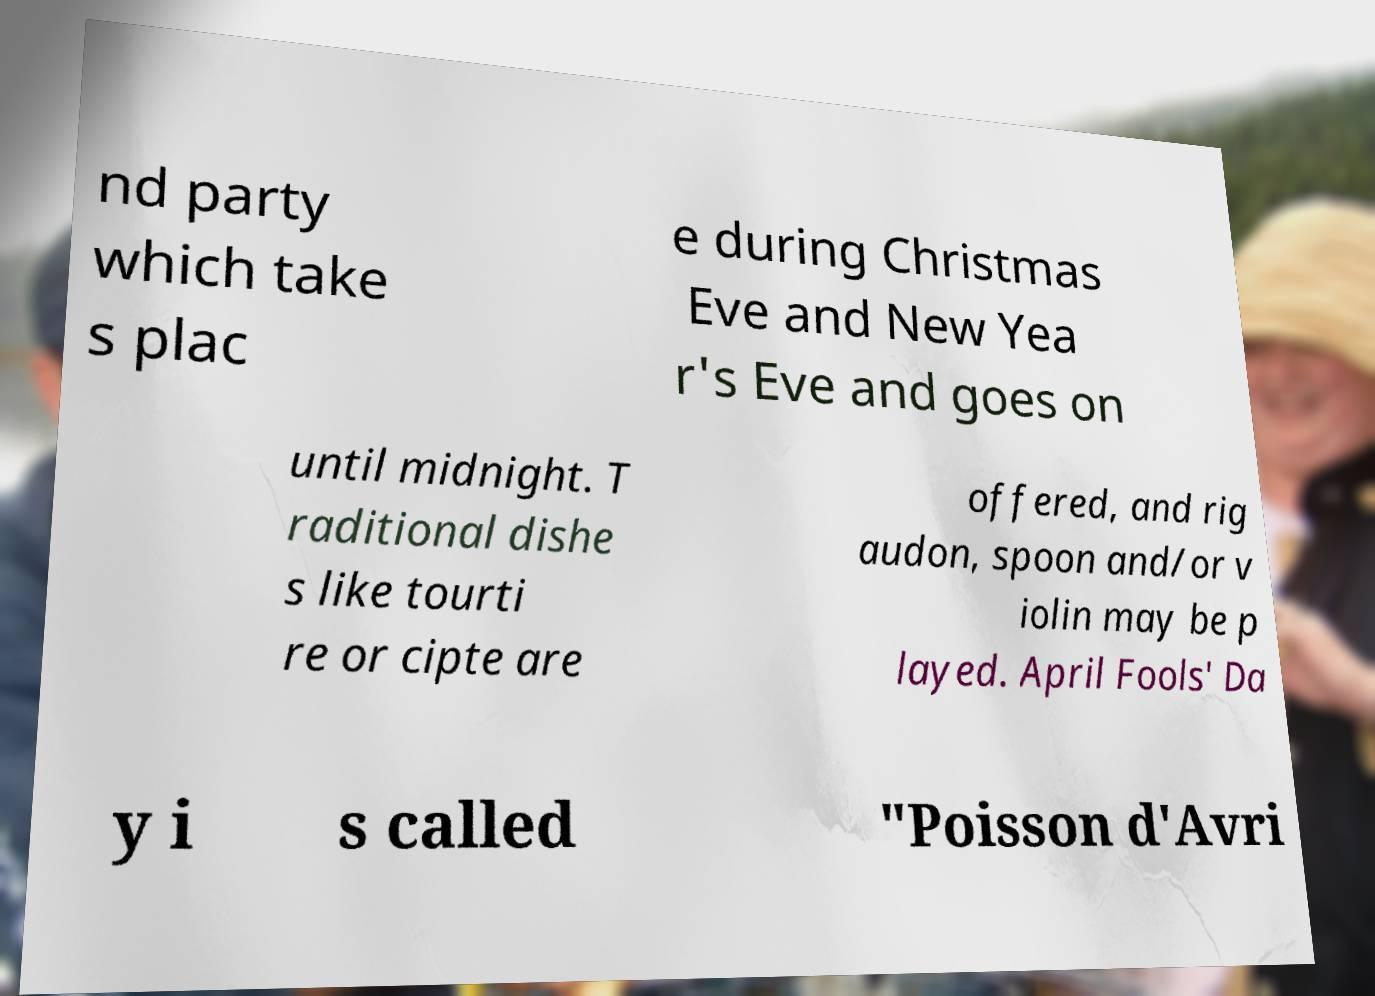Please identify and transcribe the text found in this image. nd party which take s plac e during Christmas Eve and New Yea r's Eve and goes on until midnight. T raditional dishe s like tourti re or cipte are offered, and rig audon, spoon and/or v iolin may be p layed. April Fools' Da y i s called "Poisson d'Avri 